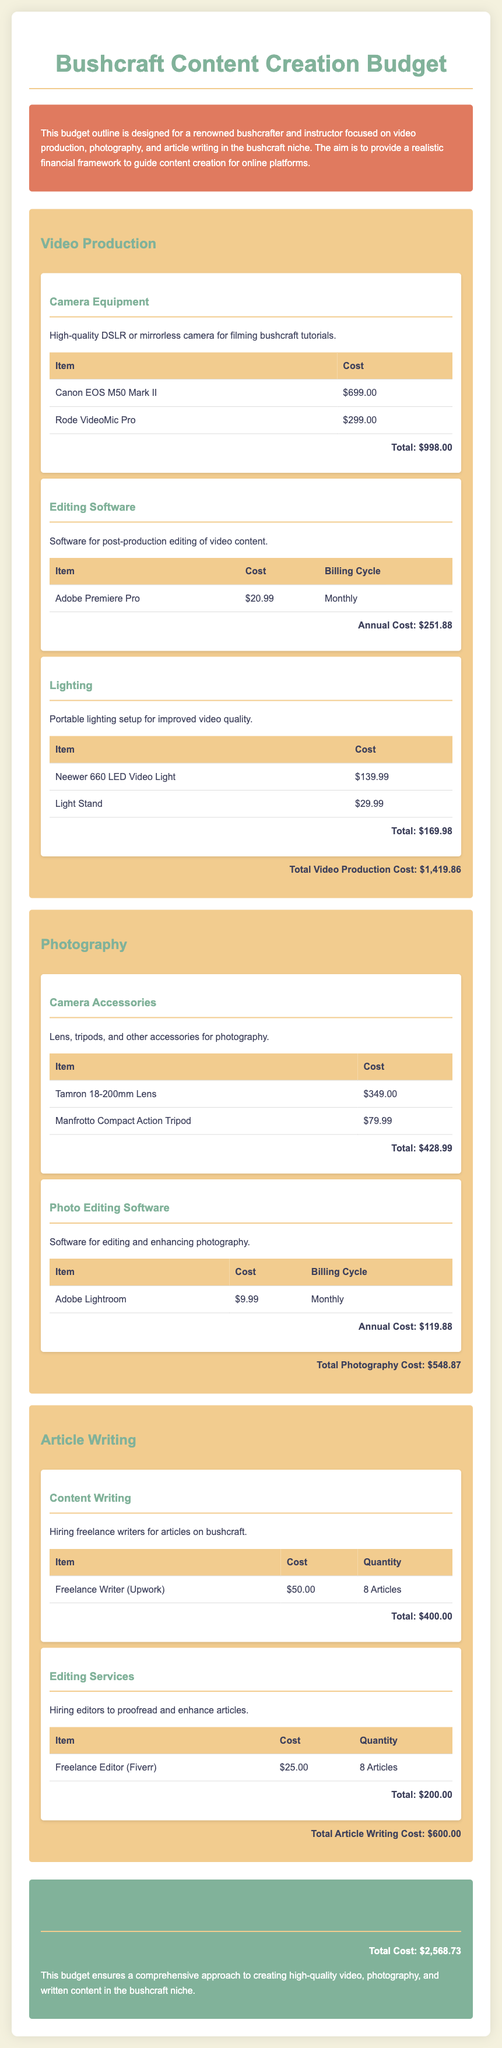What is the total cost for video production? The total cost for video production is calculated by summing the costs of camera equipment, editing software, and lighting, resulting in $1,419.86.
Answer: $1,419.86 What camera model is mentioned for video production? The document lists the Canon EOS M50 Mark II as the camera model for filming bushcraft tutorials.
Answer: Canon EOS M50 Mark II How much does the Adobe Premiere Pro cost monthly? The Adobe Premiere Pro is priced at $20.99 per month for video editing.
Answer: $20.99 What is the total photography cost? The total photography cost is obtained from summing the costs of camera accessories and photo editing software, which amounts to $548.87.
Answer: $548.87 How many articles are planned for content writing? The document states that 8 articles are planned for content writing through freelance writers.
Answer: 8 Articles What is the total cost for article writing? The total cost for article writing includes payments for content writing and editing services, totaling $600.00.
Answer: $600.00 Which lighting equipment is listed for video production? The document mentions the Neewer 660 LED Video Light as a lighting option for video production.
Answer: Neewer 660 LED Video Light What are the total expenses outlined in the budget? The grand total of all expenses for content creation across video production, photography, and article writing is calculated to be $2,568.73.
Answer: $2,568.73 What software is used for photo editing? The document lists Adobe Lightroom as the software used for editing and enhancing photography.
Answer: Adobe Lightroom 